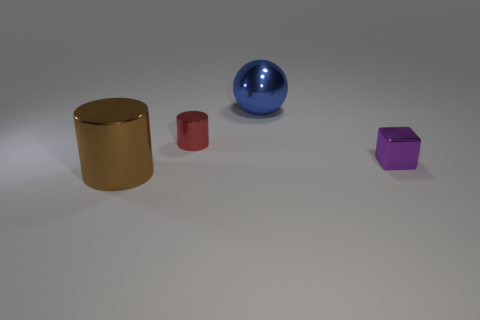How big is the metal object that is on the right side of the big blue ball?
Make the answer very short. Small. There is a red cylinder that is made of the same material as the blue object; what is its size?
Make the answer very short. Small. What number of small things have the same color as the tiny cylinder?
Provide a succinct answer. 0. Are there any red metal things?
Give a very brief answer. Yes. There is a red object; does it have the same shape as the large thing that is behind the red metallic cylinder?
Provide a short and direct response. No. There is a large metallic object behind the small object right of the large ball that is to the right of the large brown cylinder; what is its color?
Provide a succinct answer. Blue. Are there any objects to the right of the blue shiny thing?
Make the answer very short. Yes. Are there any red things that have the same material as the big brown thing?
Give a very brief answer. Yes. The large sphere has what color?
Provide a short and direct response. Blue. Is the shape of the large shiny thing in front of the purple metal object the same as  the red shiny object?
Provide a succinct answer. Yes. 